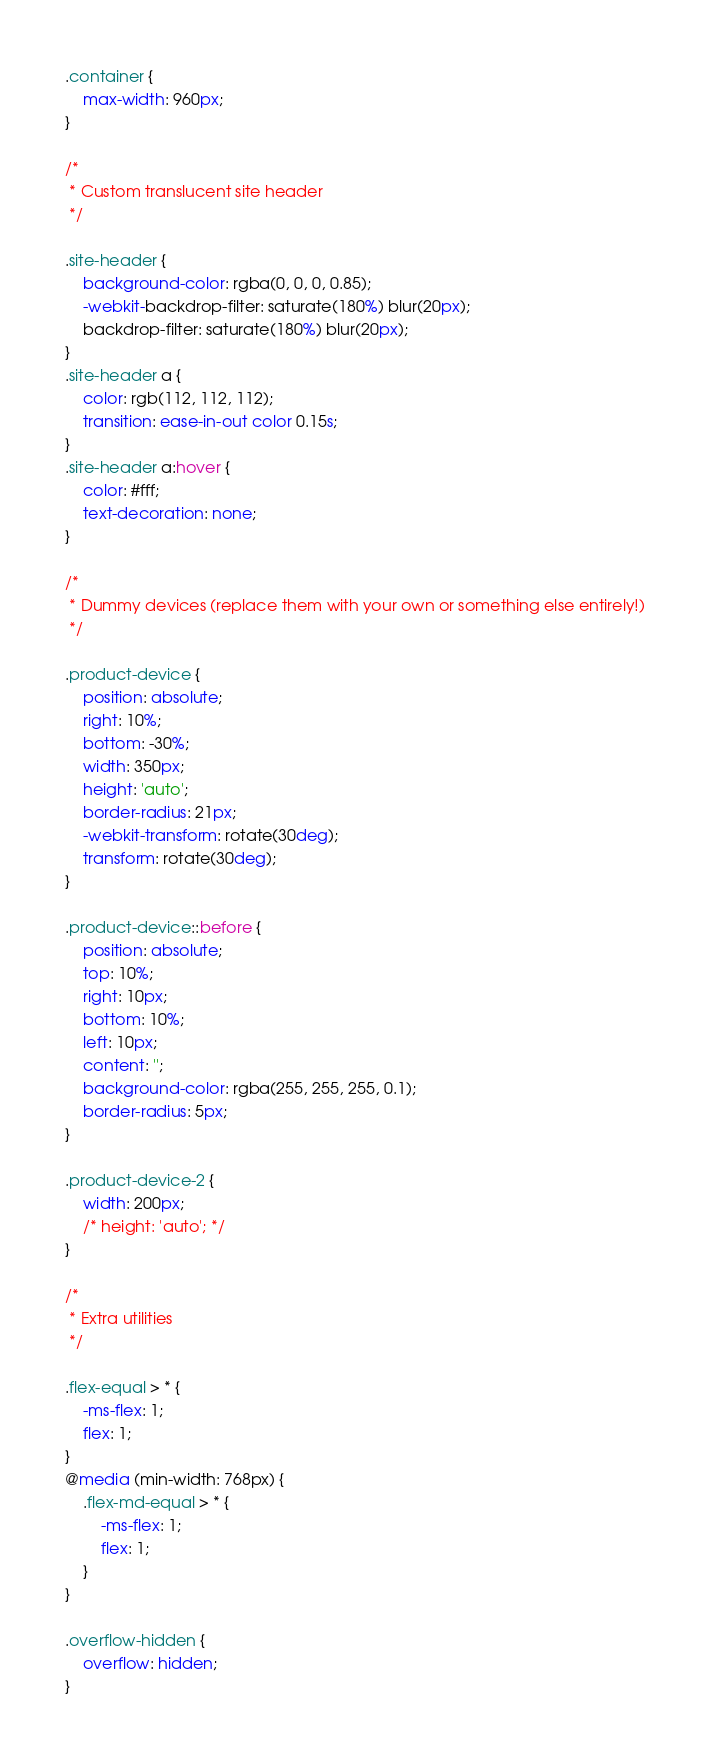<code> <loc_0><loc_0><loc_500><loc_500><_CSS_>.container {
    max-width: 960px;
}

/*
 * Custom translucent site header
 */

.site-header {
    background-color: rgba(0, 0, 0, 0.85);
    -webkit-backdrop-filter: saturate(180%) blur(20px);
    backdrop-filter: saturate(180%) blur(20px);
}
.site-header a {
    color: rgb(112, 112, 112);
    transition: ease-in-out color 0.15s;
}
.site-header a:hover {
    color: #fff;
    text-decoration: none;
}

/*
 * Dummy devices (replace them with your own or something else entirely!)
 */

.product-device {
    position: absolute;
    right: 10%;
    bottom: -30%;
    width: 350px;
    height: 'auto';
    border-radius: 21px;
    -webkit-transform: rotate(30deg);
    transform: rotate(30deg);
}

.product-device::before {
    position: absolute;
    top: 10%;
    right: 10px;
    bottom: 10%;
    left: 10px;
    content: '';
    background-color: rgba(255, 255, 255, 0.1);
    border-radius: 5px;
}

.product-device-2 {
    width: 200px;
    /* height: 'auto'; */
}

/*
 * Extra utilities
 */

.flex-equal > * {
    -ms-flex: 1;
    flex: 1;
}
@media (min-width: 768px) {
    .flex-md-equal > * {
        -ms-flex: 1;
        flex: 1;
    }
}

.overflow-hidden {
    overflow: hidden;
}
</code> 